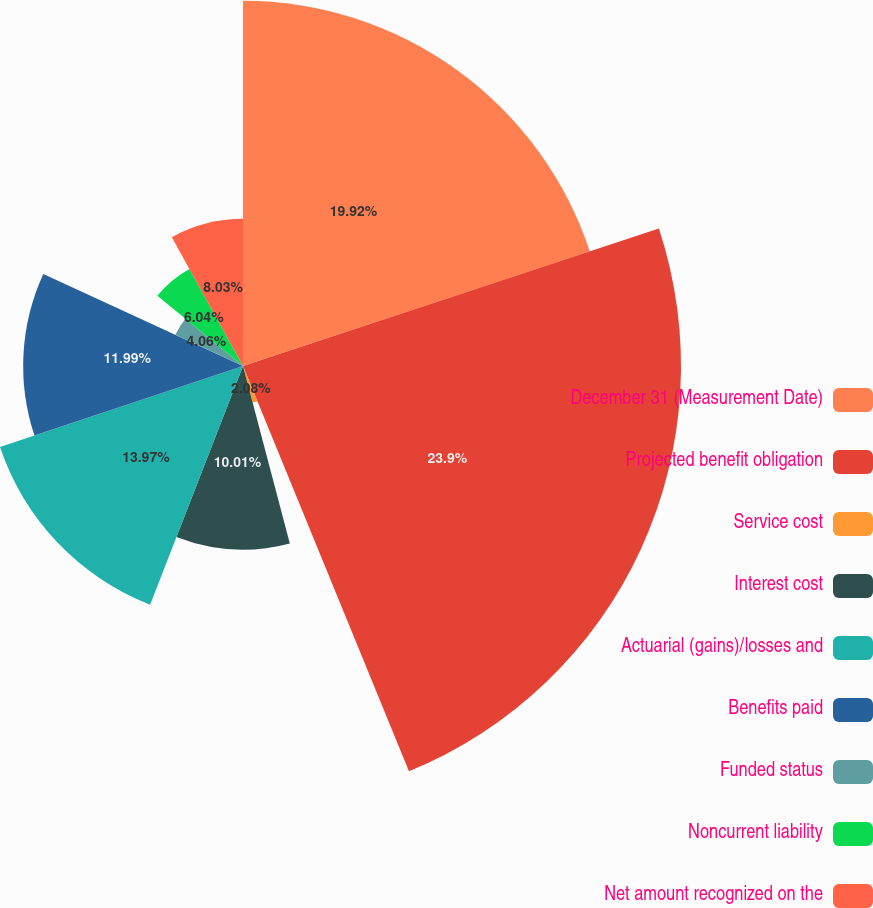Convert chart to OTSL. <chart><loc_0><loc_0><loc_500><loc_500><pie_chart><fcel>December 31 (Measurement Date)<fcel>Projected benefit obligation<fcel>Service cost<fcel>Interest cost<fcel>Actuarial (gains)/losses and<fcel>Benefits paid<fcel>Funded status<fcel>Noncurrent liability<fcel>Net amount recognized on the<nl><fcel>19.92%<fcel>23.89%<fcel>2.08%<fcel>10.01%<fcel>13.97%<fcel>11.99%<fcel>4.06%<fcel>6.04%<fcel>8.03%<nl></chart> 